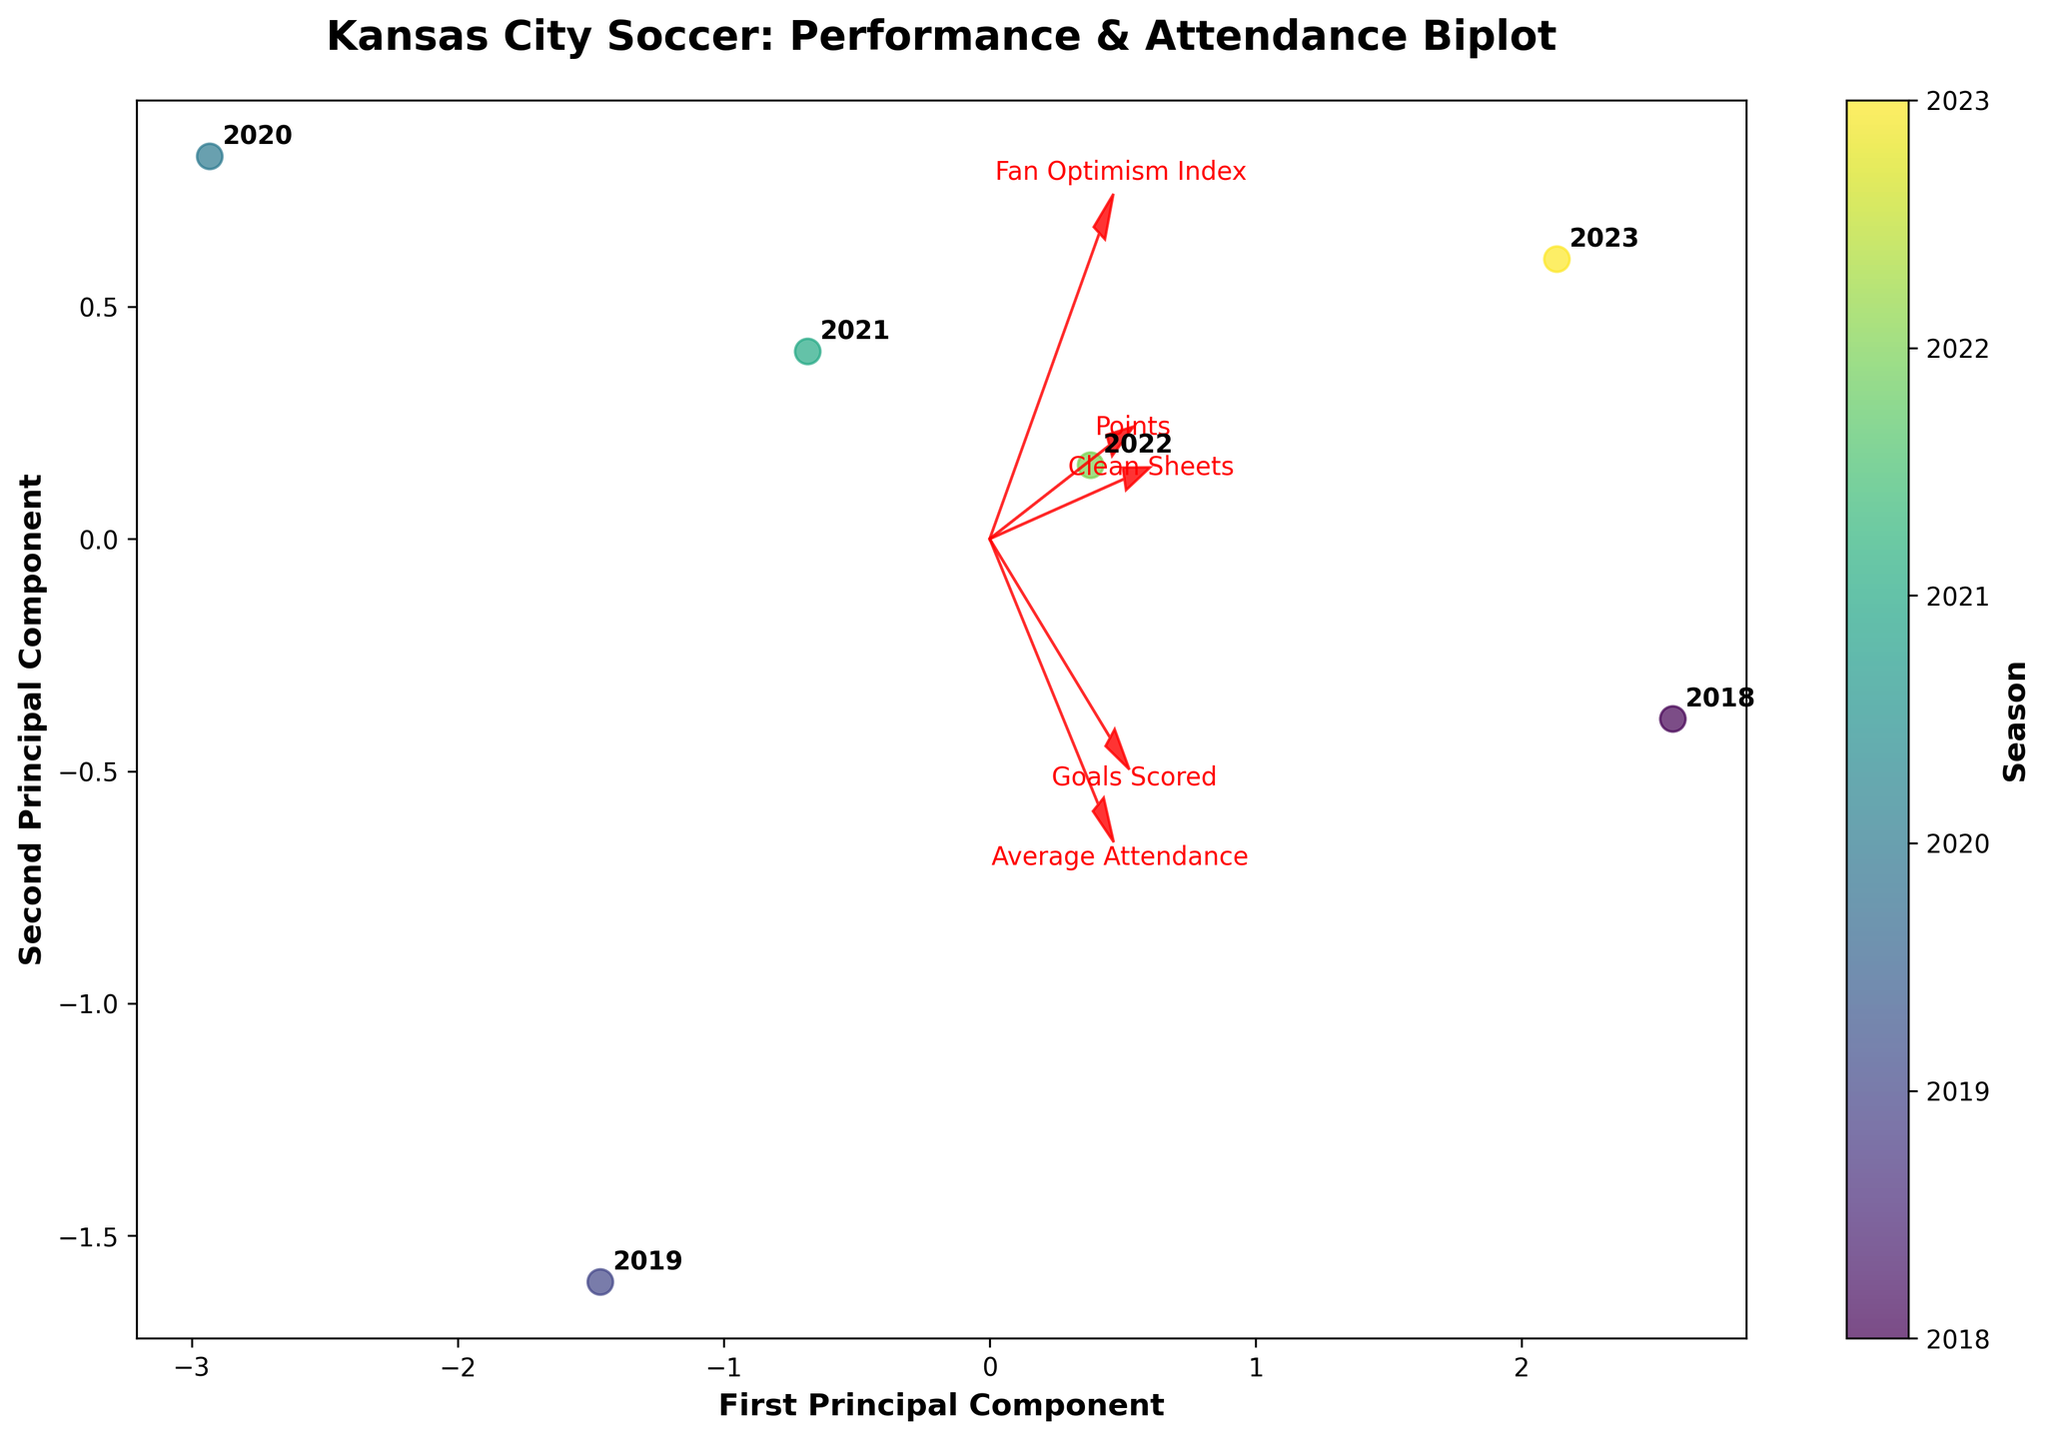What's the title of the plot? The title of the plot is located at the top center of the figure, typically in a larger and bold font.
Answer: Kansas City Soccer: Performance & Attendance Biplot Which principal component is plotted on the x-axis? The x-axis label indicates which principal component is shown there. Look for text like "First Principal Component."
Answer: First Principal Component What is the unique color for each season? The color encoding of each season is shown in the color bar, which maps specific colors to each unique season listed.
Answer: Unique color per season, as shown in the color bar How many data points are in the plot? Each data point represents a season. Count the number of distinct data points plotted in the scatter plot.
Answer: 6 data points Which feature has the longest arrow? Compare the length of the red arrows representing different features. The longest arrow corresponds to the feature with the greatest influence in the PCA.
Answer: Objectives have the longest arrow In which season does the first principal component (PC1) have the highest value? Check the scatter plot to find the data point furthest to the right on the x-axis, noting the season annotated near it.
Answer: 2018 season Which feature is most positively correlated with the second principal component (PC2)? Look at the direction of the arrows indicating features. The feature pointing most upwards is most positively correlated with PC2.
Answer: Fan Optimism Index What relationship between average attendance and fan optimism index can be inferred from the plot? Observe the arrows for average attendance and fan optimism index. If they point in similar directions, they are positively correlated; if opposite, negatively.
Answer: They are positively correlated Which season shows a relatively balanced performance in both components? Identify the data point closest to the origin (0,0), indicating a balanced performance in both principal components.
Answer: 2021 season Based on the biplot, which feature appears to contribute least to PC1? Check the components and their projections on PC1. The shortest arrow or smallest projection on the x-axis denotes the least contributing feature.
Answer: Clean Sheets 